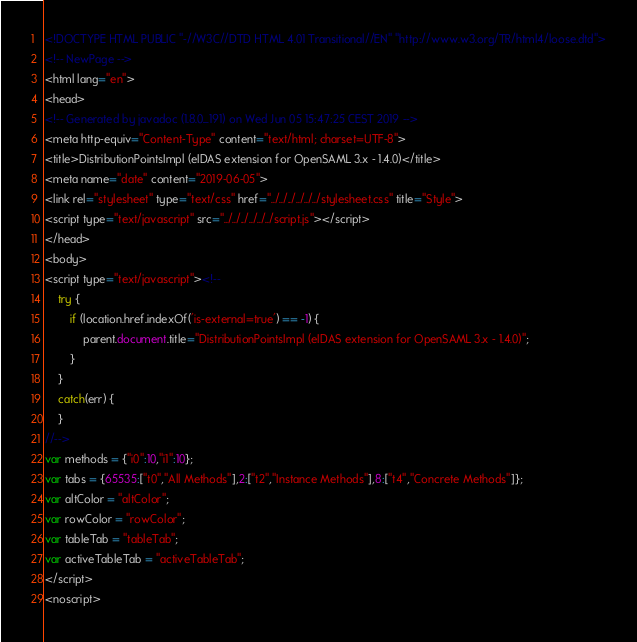Convert code to text. <code><loc_0><loc_0><loc_500><loc_500><_HTML_><!DOCTYPE HTML PUBLIC "-//W3C//DTD HTML 4.01 Transitional//EN" "http://www.w3.org/TR/html4/loose.dtd">
<!-- NewPage -->
<html lang="en">
<head>
<!-- Generated by javadoc (1.8.0_191) on Wed Jun 05 15:47:25 CEST 2019 -->
<meta http-equiv="Content-Type" content="text/html; charset=UTF-8">
<title>DistributionPointsImpl (eIDAS extension for OpenSAML 3.x - 1.4.0)</title>
<meta name="date" content="2019-06-05">
<link rel="stylesheet" type="text/css" href="../../../../../../stylesheet.css" title="Style">
<script type="text/javascript" src="../../../../../../script.js"></script>
</head>
<body>
<script type="text/javascript"><!--
    try {
        if (location.href.indexOf('is-external=true') == -1) {
            parent.document.title="DistributionPointsImpl (eIDAS extension for OpenSAML 3.x - 1.4.0)";
        }
    }
    catch(err) {
    }
//-->
var methods = {"i0":10,"i1":10};
var tabs = {65535:["t0","All Methods"],2:["t2","Instance Methods"],8:["t4","Concrete Methods"]};
var altColor = "altColor";
var rowColor = "rowColor";
var tableTab = "tableTab";
var activeTableTab = "activeTableTab";
</script>
<noscript></code> 